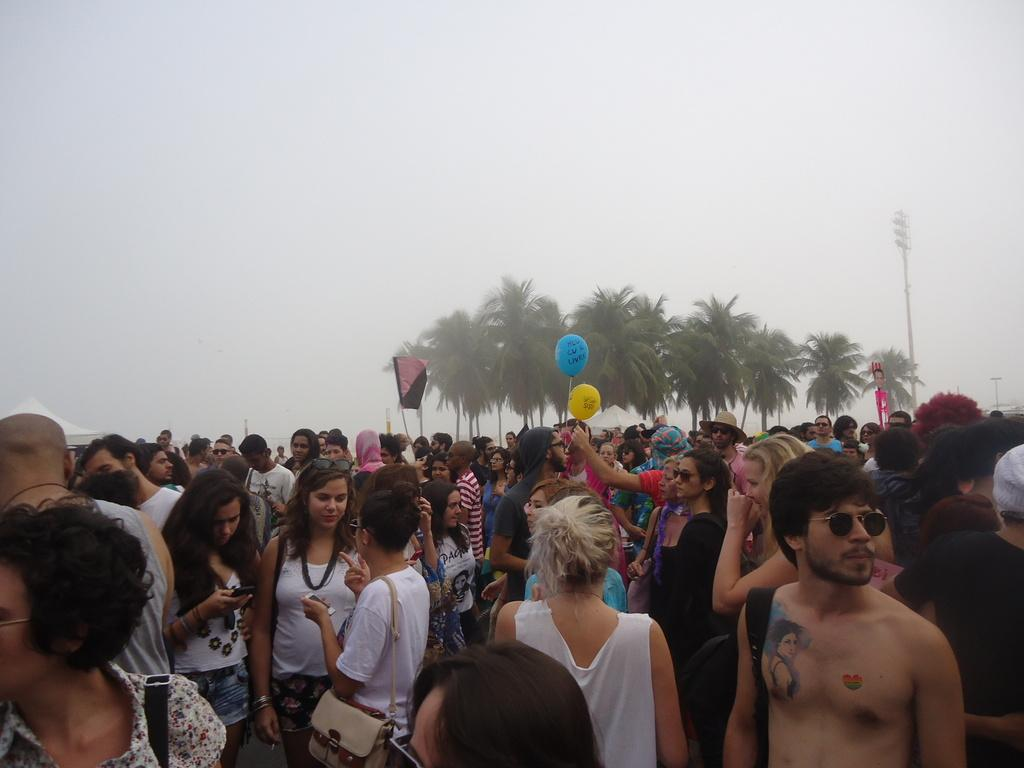What is happening in the image? There are people standing in the image. What can be seen in the background of the image? There are balloons, a flag, trees, a red color board, and a pole in the background of the image. What type of skate is being used by the people in the image? There is no skate present in the image; the people are simply standing. What kind of system is being used to organize the balloons in the image? There is no system visible for organizing the balloons in the image; they are simply floating in the background. 